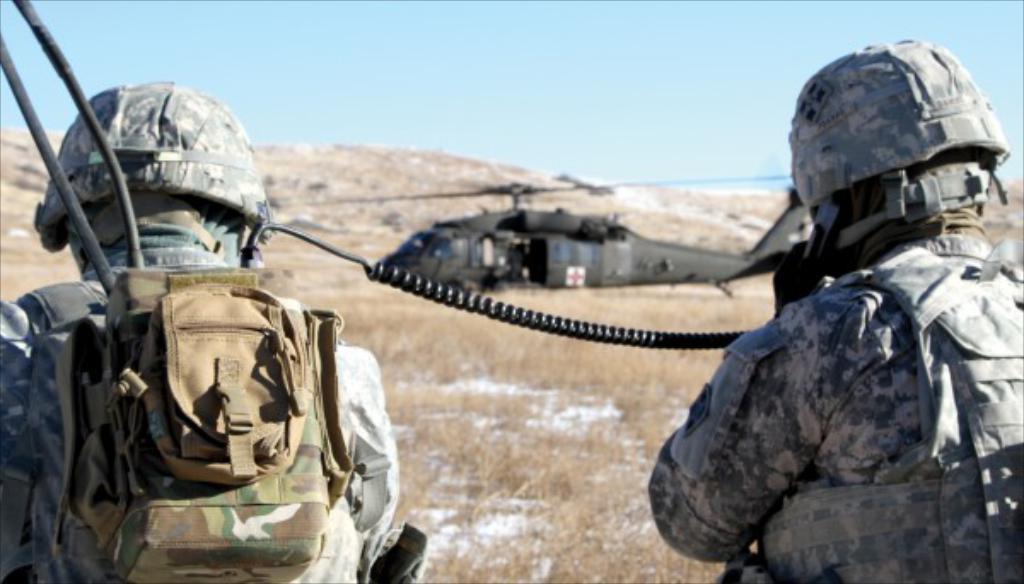Could you give a brief overview of what you see in this image? In this image we can see some persons, bag and other objects. In the background of the image there is a helicopter, hill and other objects. At the top of the image there is the sky. 